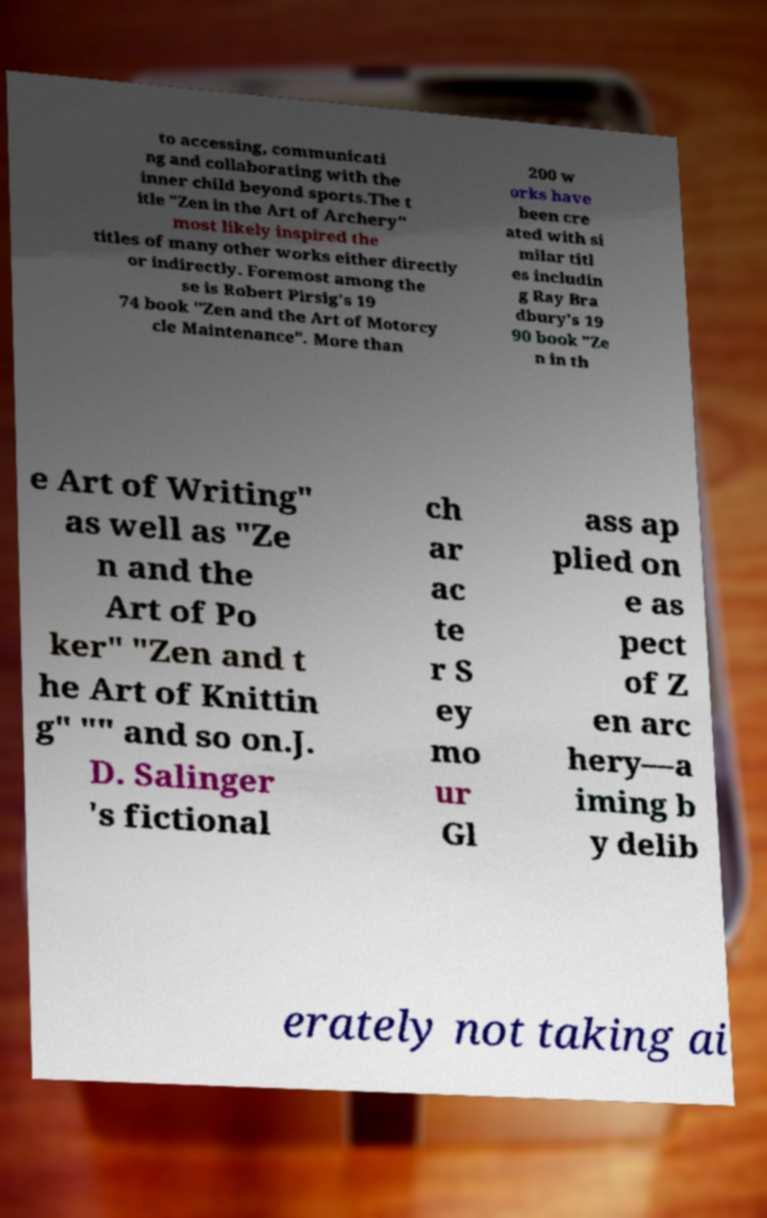Could you extract and type out the text from this image? to accessing, communicati ng and collaborating with the inner child beyond sports.The t itle "Zen in the Art of Archery" most likely inspired the titles of many other works either directly or indirectly. Foremost among the se is Robert Pirsig's 19 74 book "Zen and the Art of Motorcy cle Maintenance". More than 200 w orks have been cre ated with si milar titl es includin g Ray Bra dbury's 19 90 book "Ze n in th e Art of Writing" as well as "Ze n and the Art of Po ker" "Zen and t he Art of Knittin g" "" and so on.J. D. Salinger 's fictional ch ar ac te r S ey mo ur Gl ass ap plied on e as pect of Z en arc hery—a iming b y delib erately not taking ai 